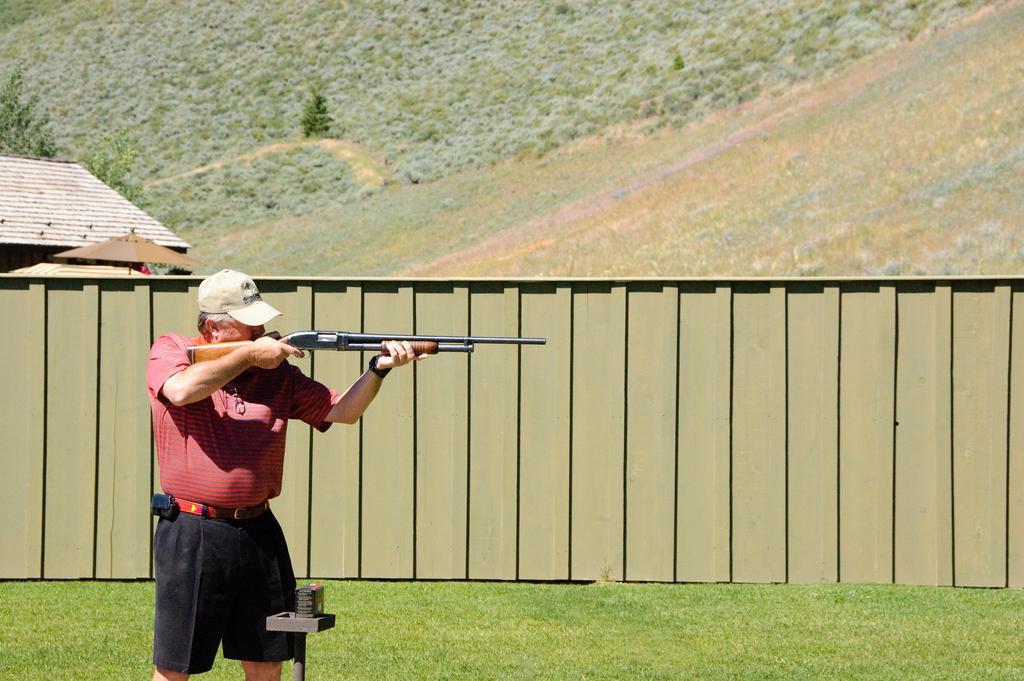Can you describe this image briefly? In the image we can see a person standing, wearing clothes, cap and the person is holding a rifle in his hands. Here we can see the grass, wall and plants.  